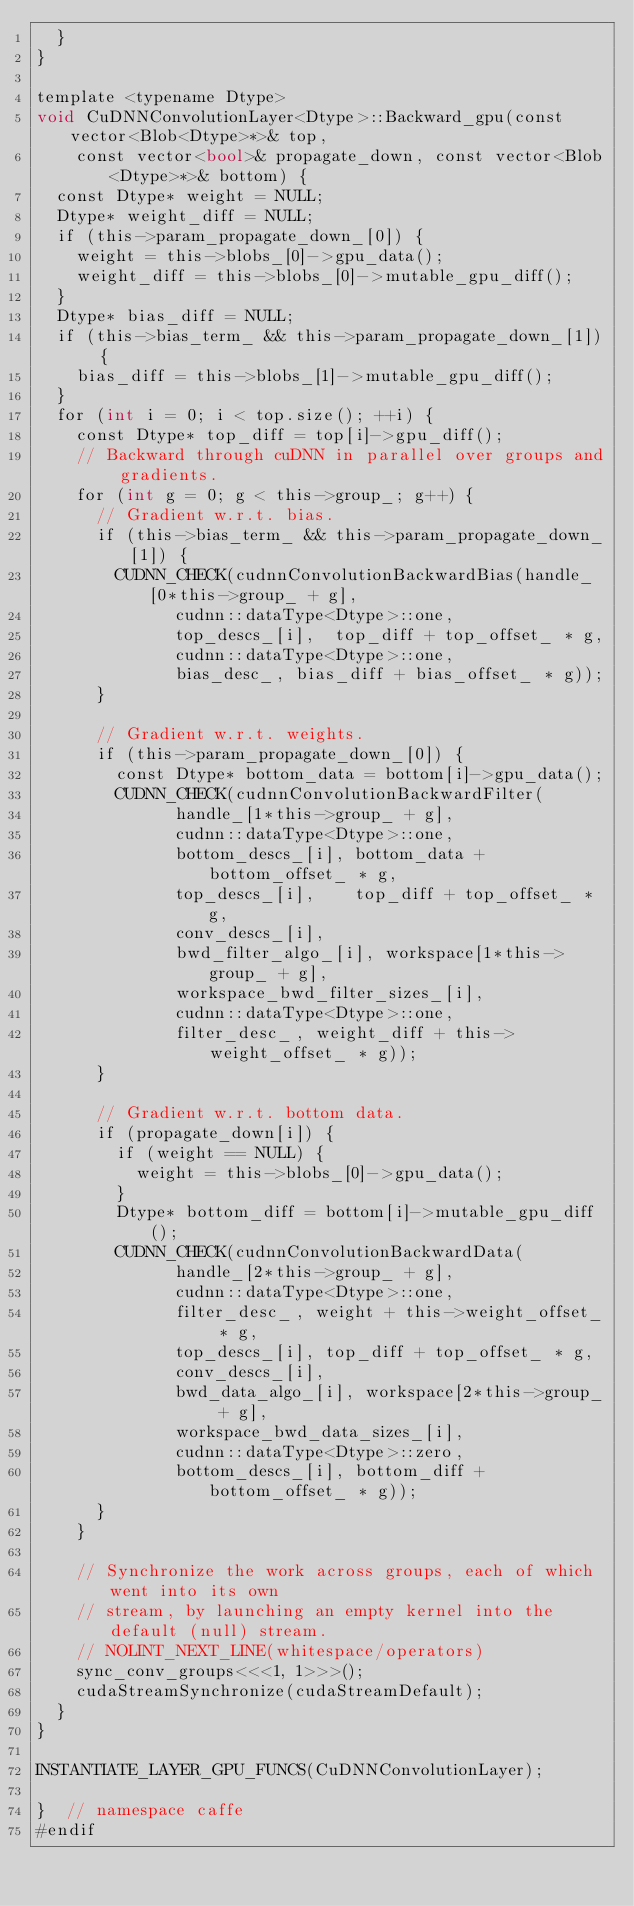<code> <loc_0><loc_0><loc_500><loc_500><_Cuda_>  }
}

template <typename Dtype>
void CuDNNConvolutionLayer<Dtype>::Backward_gpu(const vector<Blob<Dtype>*>& top,
    const vector<bool>& propagate_down, const vector<Blob<Dtype>*>& bottom) {
  const Dtype* weight = NULL;
  Dtype* weight_diff = NULL;
  if (this->param_propagate_down_[0]) {
    weight = this->blobs_[0]->gpu_data();
    weight_diff = this->blobs_[0]->mutable_gpu_diff();
  }
  Dtype* bias_diff = NULL;
  if (this->bias_term_ && this->param_propagate_down_[1]) {
    bias_diff = this->blobs_[1]->mutable_gpu_diff();
  }
  for (int i = 0; i < top.size(); ++i) {
    const Dtype* top_diff = top[i]->gpu_diff();
    // Backward through cuDNN in parallel over groups and gradients.
    for (int g = 0; g < this->group_; g++) {
      // Gradient w.r.t. bias.
      if (this->bias_term_ && this->param_propagate_down_[1]) {
        CUDNN_CHECK(cudnnConvolutionBackwardBias(handle_[0*this->group_ + g],
              cudnn::dataType<Dtype>::one,
              top_descs_[i],  top_diff + top_offset_ * g,
              cudnn::dataType<Dtype>::one,
              bias_desc_, bias_diff + bias_offset_ * g));
      }

      // Gradient w.r.t. weights.
      if (this->param_propagate_down_[0]) {
        const Dtype* bottom_data = bottom[i]->gpu_data();
        CUDNN_CHECK(cudnnConvolutionBackwardFilter(
              handle_[1*this->group_ + g],
              cudnn::dataType<Dtype>::one,
              bottom_descs_[i], bottom_data + bottom_offset_ * g,
              top_descs_[i],    top_diff + top_offset_ * g,
              conv_descs_[i],
              bwd_filter_algo_[i], workspace[1*this->group_ + g],
              workspace_bwd_filter_sizes_[i],
              cudnn::dataType<Dtype>::one,
              filter_desc_, weight_diff + this->weight_offset_ * g));
      }

      // Gradient w.r.t. bottom data.
      if (propagate_down[i]) {
        if (weight == NULL) {
          weight = this->blobs_[0]->gpu_data();
        }
        Dtype* bottom_diff = bottom[i]->mutable_gpu_diff();
        CUDNN_CHECK(cudnnConvolutionBackwardData(
              handle_[2*this->group_ + g],
              cudnn::dataType<Dtype>::one,
              filter_desc_, weight + this->weight_offset_ * g,
              top_descs_[i], top_diff + top_offset_ * g,
              conv_descs_[i],
              bwd_data_algo_[i], workspace[2*this->group_ + g],
              workspace_bwd_data_sizes_[i],
              cudnn::dataType<Dtype>::zero,
              bottom_descs_[i], bottom_diff + bottom_offset_ * g));
      }
    }

    // Synchronize the work across groups, each of which went into its own
    // stream, by launching an empty kernel into the default (null) stream.
    // NOLINT_NEXT_LINE(whitespace/operators)
    sync_conv_groups<<<1, 1>>>();
    cudaStreamSynchronize(cudaStreamDefault);
  }
}

INSTANTIATE_LAYER_GPU_FUNCS(CuDNNConvolutionLayer);

}  // namespace caffe
#endif
</code> 